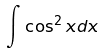<formula> <loc_0><loc_0><loc_500><loc_500>\int \cos ^ { 2 } x d x</formula> 